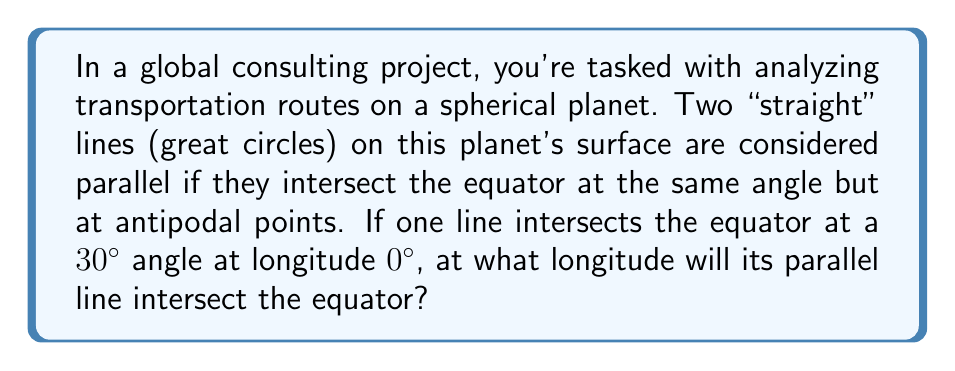Solve this math problem. Let's approach this step-by-step:

1) In elliptic geometry (geometry on a sphere), parallel lines are defined differently than in Euclidean geometry. They intersect the equator at the same angle but at antipodal points.

2) Antipodal points on a sphere are points that are diametrically opposite to each other. They are connected by a straight line that passes through the center of the sphere.

3) On the surface of a sphere, the distance between any two antipodal points along a great circle is always half the circumference of the sphere, which is 180° in terms of longitude.

4) Given:
   - One line intersects the equator at 30° angle at longitude 0°
   - The parallel line must intersect at the same 30° angle

5) To find the antipodal point of 0° longitude:
   $$0° + 180° = 180°$$

Therefore, the parallel line will intersect the equator at 180° longitude.

This can be visualized as follows:

[asy]
import geometry;

size(200);
draw(Circle((0,0),1));
draw((0,-1)--(0,1),blue);
draw((-1,0)--(1,0),blue);
draw((-0.866,-0.5)--(0.866,0.5),red);
draw((0.866,-0.5)--(-0.866,0.5),red);
label("0°",(1,0),E);
label("180°",(-1,0),W);
label("30°",(0.866,-0.5),SE);
label("30°",(-0.866,0.5),NW);
[/asy]

In this diagram, the blue lines represent the equator and the prime meridian, while the red lines represent the parallel great circles intersecting the equator at 30° angles at 0° and 180° longitudes.
Answer: 180° 